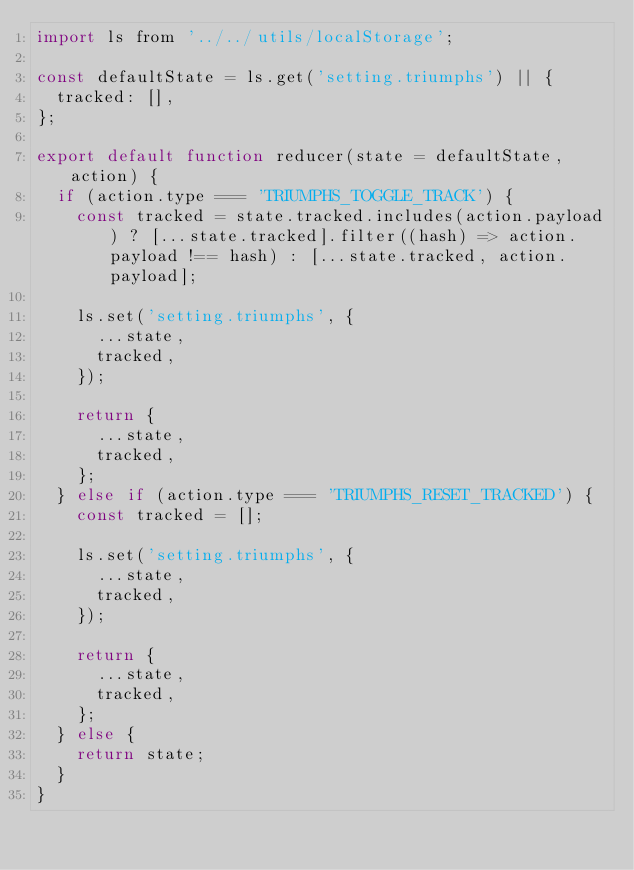Convert code to text. <code><loc_0><loc_0><loc_500><loc_500><_JavaScript_>import ls from '../../utils/localStorage';

const defaultState = ls.get('setting.triumphs') || {
  tracked: [],
};

export default function reducer(state = defaultState, action) {
  if (action.type === 'TRIUMPHS_TOGGLE_TRACK') {
    const tracked = state.tracked.includes(action.payload) ? [...state.tracked].filter((hash) => action.payload !== hash) : [...state.tracked, action.payload];

    ls.set('setting.triumphs', {
      ...state,
      tracked,
    });

    return {
      ...state,
      tracked,
    };
  } else if (action.type === 'TRIUMPHS_RESET_TRACKED') {
    const tracked = [];

    ls.set('setting.triumphs', {
      ...state,
      tracked,
    });

    return {
      ...state,
      tracked,
    };
  } else {
    return state;
  }
}
</code> 